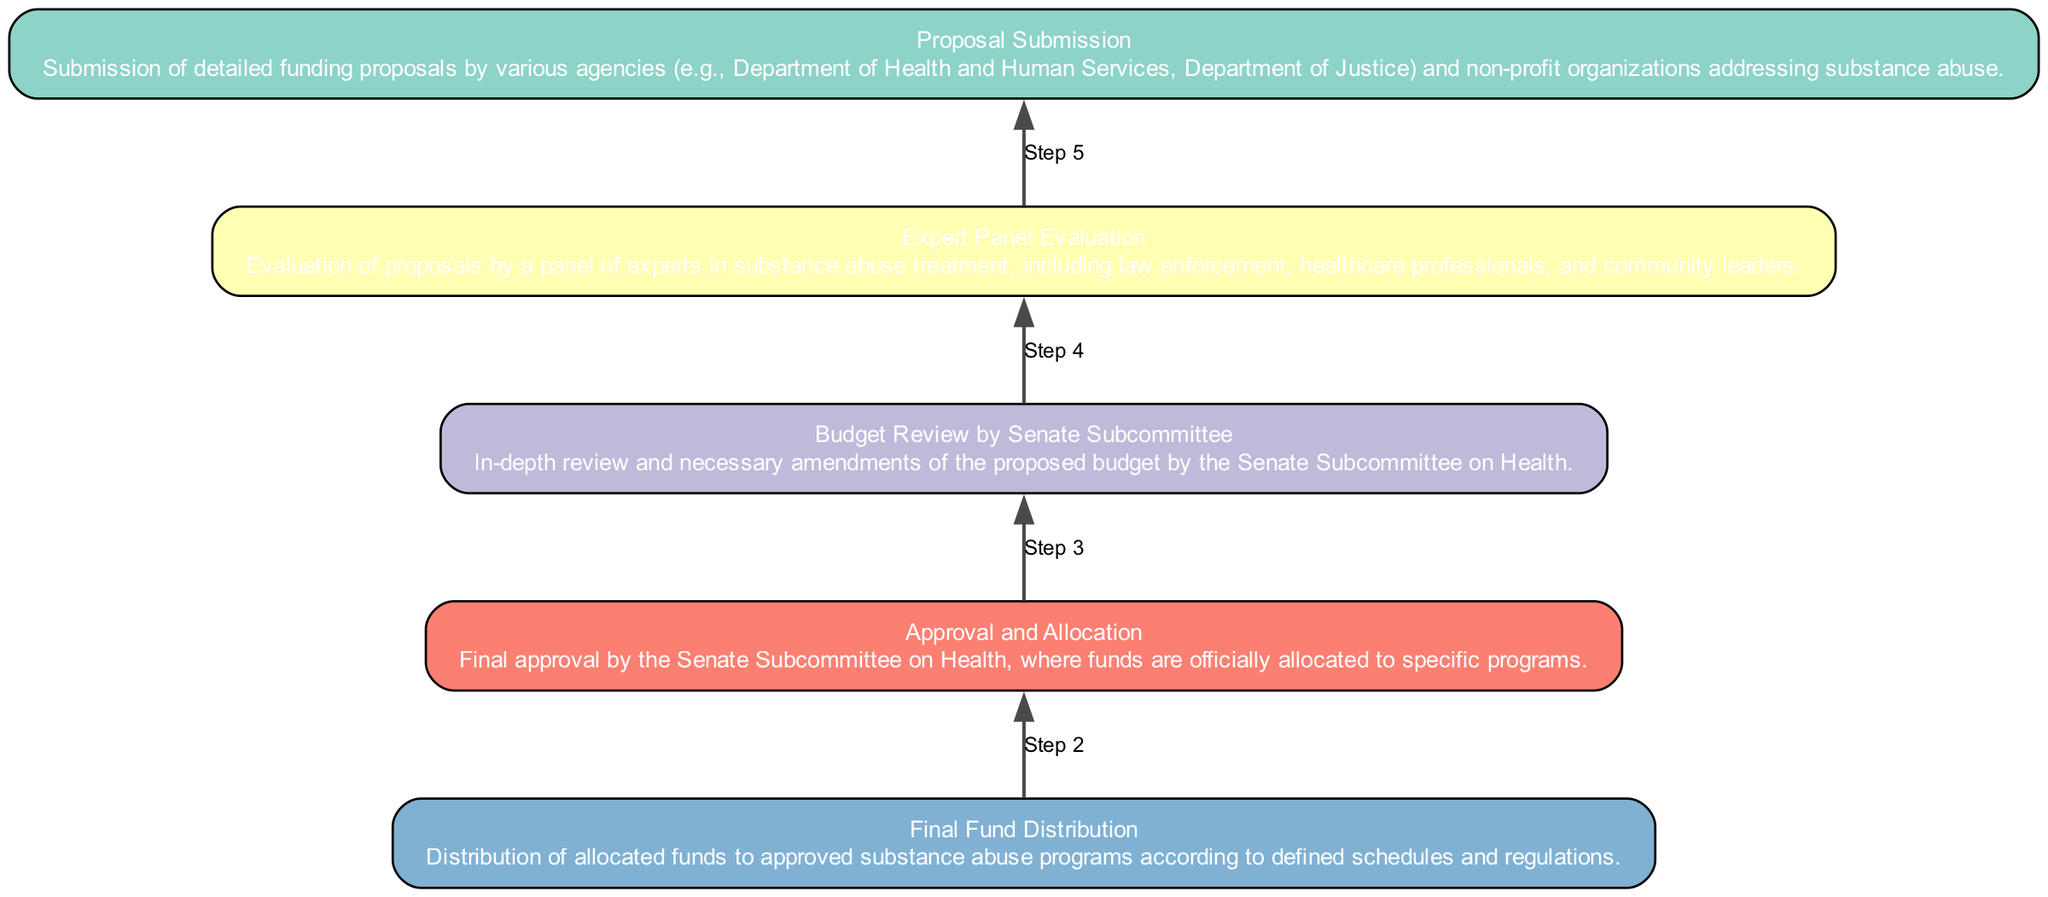What is the final step in the budget allocation process? The final step is "Final Fund Distribution", which indicates where allocated funds are distributed to approved substance abuse programs.
Answer: Final Fund Distribution Which level does "Expert Panel Evaluation" belong to? "Expert Panel Evaluation" is at level 4, according to the arrangement listed in the data.
Answer: Level 4 How many nodes are in the diagram? There are a total of 5 nodes representing different steps in the budget allocation process.
Answer: 5 What follows after "Proposal Submission"? "Expert Panel Evaluation" follows after "Proposal Submission", as it is the next step in the process flow.
Answer: Expert Panel Evaluation At which step does the Senate Subcommittee officially allocate the funds? The official allocation of funds occurs during the "Approval and Allocation" step.
Answer: Approval and Allocation What is the relationship between "Budget Review by Senate Subcommittee" and "Approval and Allocation"? "Budget Review by Senate Subcommittee" comes before "Approval and Allocation", as it involves reviewing and amending the proposed budget prior to final approval.
Answer: Comes before What role do experts play in the proposed budget process? Experts evaluate the proposals in "Expert Panel Evaluation", which is essential for assessing the viability and effectiveness of the funding requests.
Answer: Evaluate How many steps are there between "Proposal Submission" and "Final Fund Distribution"? There are three steps between "Proposal Submission" and "Final Fund Distribution": "Expert Panel Evaluation", "Budget Review by Senate Subcommittee", and "Approval and Allocation".
Answer: Three steps What is the purpose of "Budget Review by Senate Subcommittee"? The purpose of the "Budget Review by Senate Subcommittee" is to conduct an in-depth review and make necessary amendments to the proposed budget before it is approved.
Answer: In-depth review and amendments 